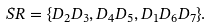Convert formula to latex. <formula><loc_0><loc_0><loc_500><loc_500>S R = \{ D _ { 2 } D _ { 3 } , D _ { 4 } D _ { 5 } , D _ { 1 } D _ { 6 } D _ { 7 } \} .</formula> 